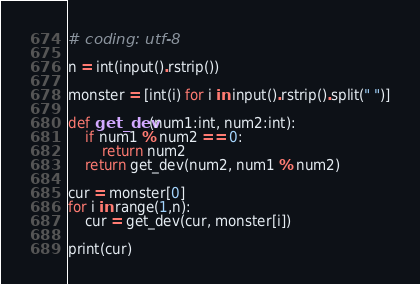Convert code to text. <code><loc_0><loc_0><loc_500><loc_500><_Python_># coding: utf-8

n = int(input().rstrip())

monster = [int(i) for i in input().rstrip().split(" ")]

def get_dev(num1:int, num2:int):
    if num1 % num2 == 0:
        return num2
    return get_dev(num2, num1 % num2)

cur = monster[0]
for i in range(1,n):
    cur = get_dev(cur, monster[i])

print(cur)
</code> 